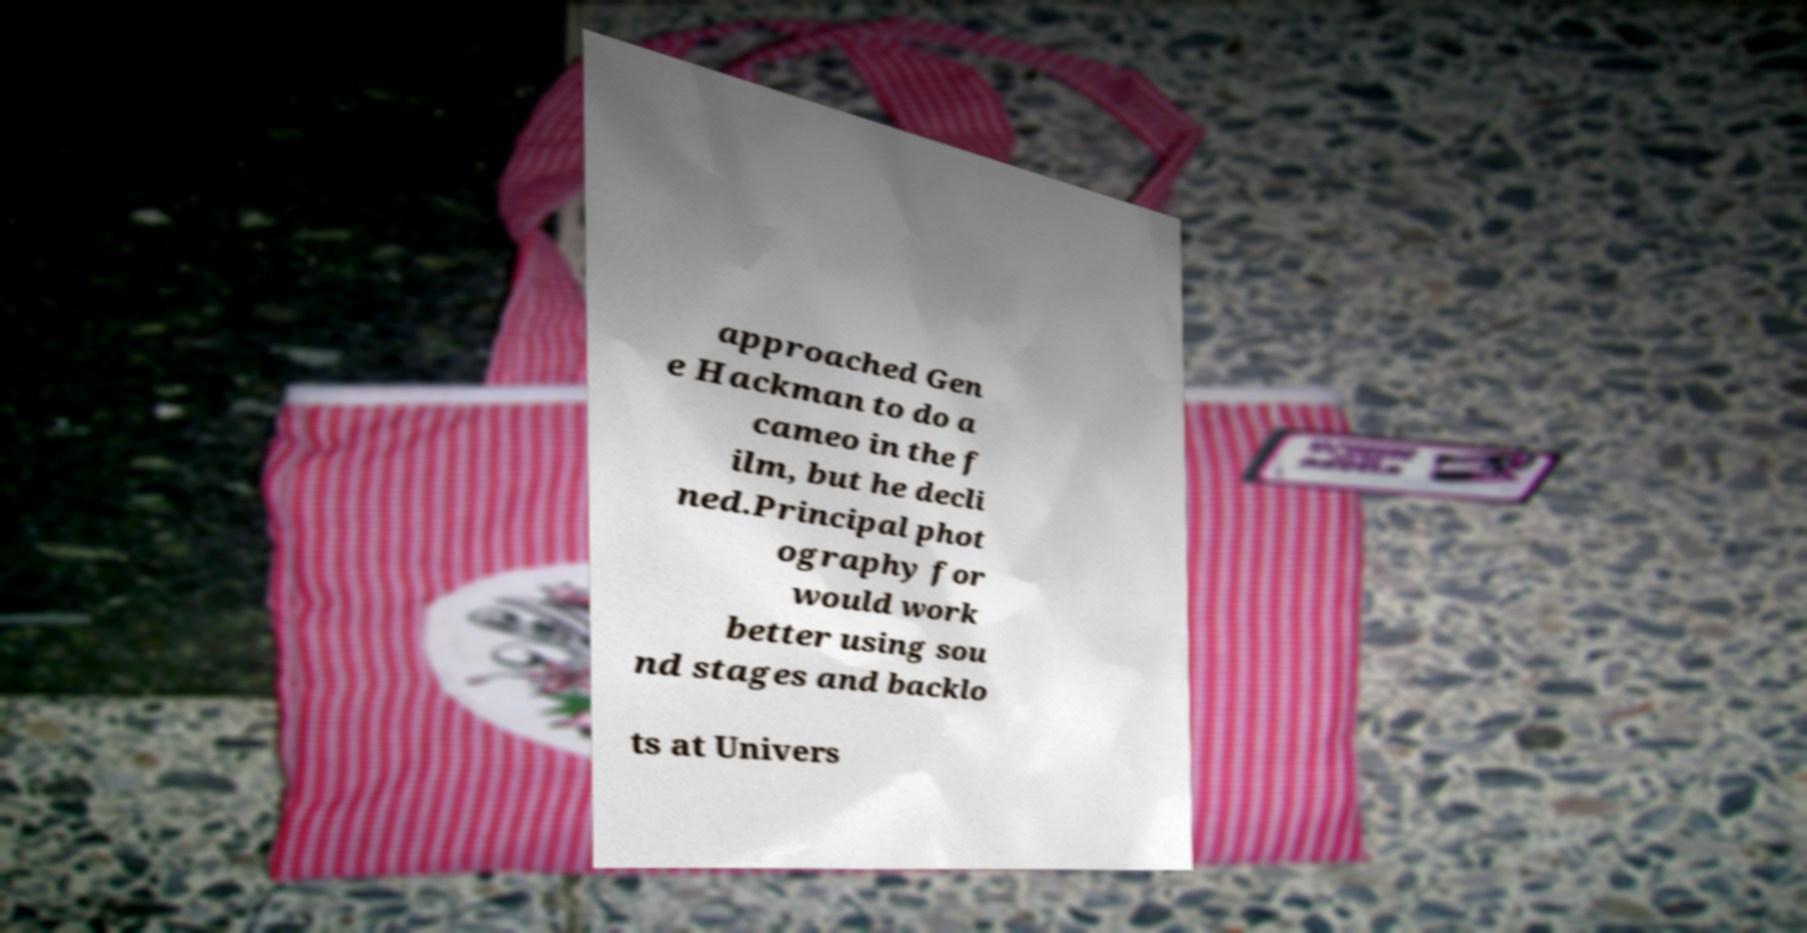Can you accurately transcribe the text from the provided image for me? approached Gen e Hackman to do a cameo in the f ilm, but he decli ned.Principal phot ography for would work better using sou nd stages and backlo ts at Univers 